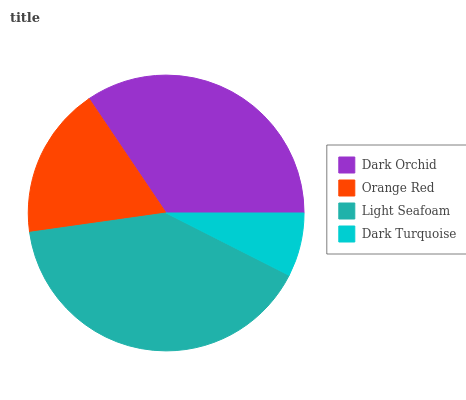Is Dark Turquoise the minimum?
Answer yes or no. Yes. Is Light Seafoam the maximum?
Answer yes or no. Yes. Is Orange Red the minimum?
Answer yes or no. No. Is Orange Red the maximum?
Answer yes or no. No. Is Dark Orchid greater than Orange Red?
Answer yes or no. Yes. Is Orange Red less than Dark Orchid?
Answer yes or no. Yes. Is Orange Red greater than Dark Orchid?
Answer yes or no. No. Is Dark Orchid less than Orange Red?
Answer yes or no. No. Is Dark Orchid the high median?
Answer yes or no. Yes. Is Orange Red the low median?
Answer yes or no. Yes. Is Light Seafoam the high median?
Answer yes or no. No. Is Dark Orchid the low median?
Answer yes or no. No. 